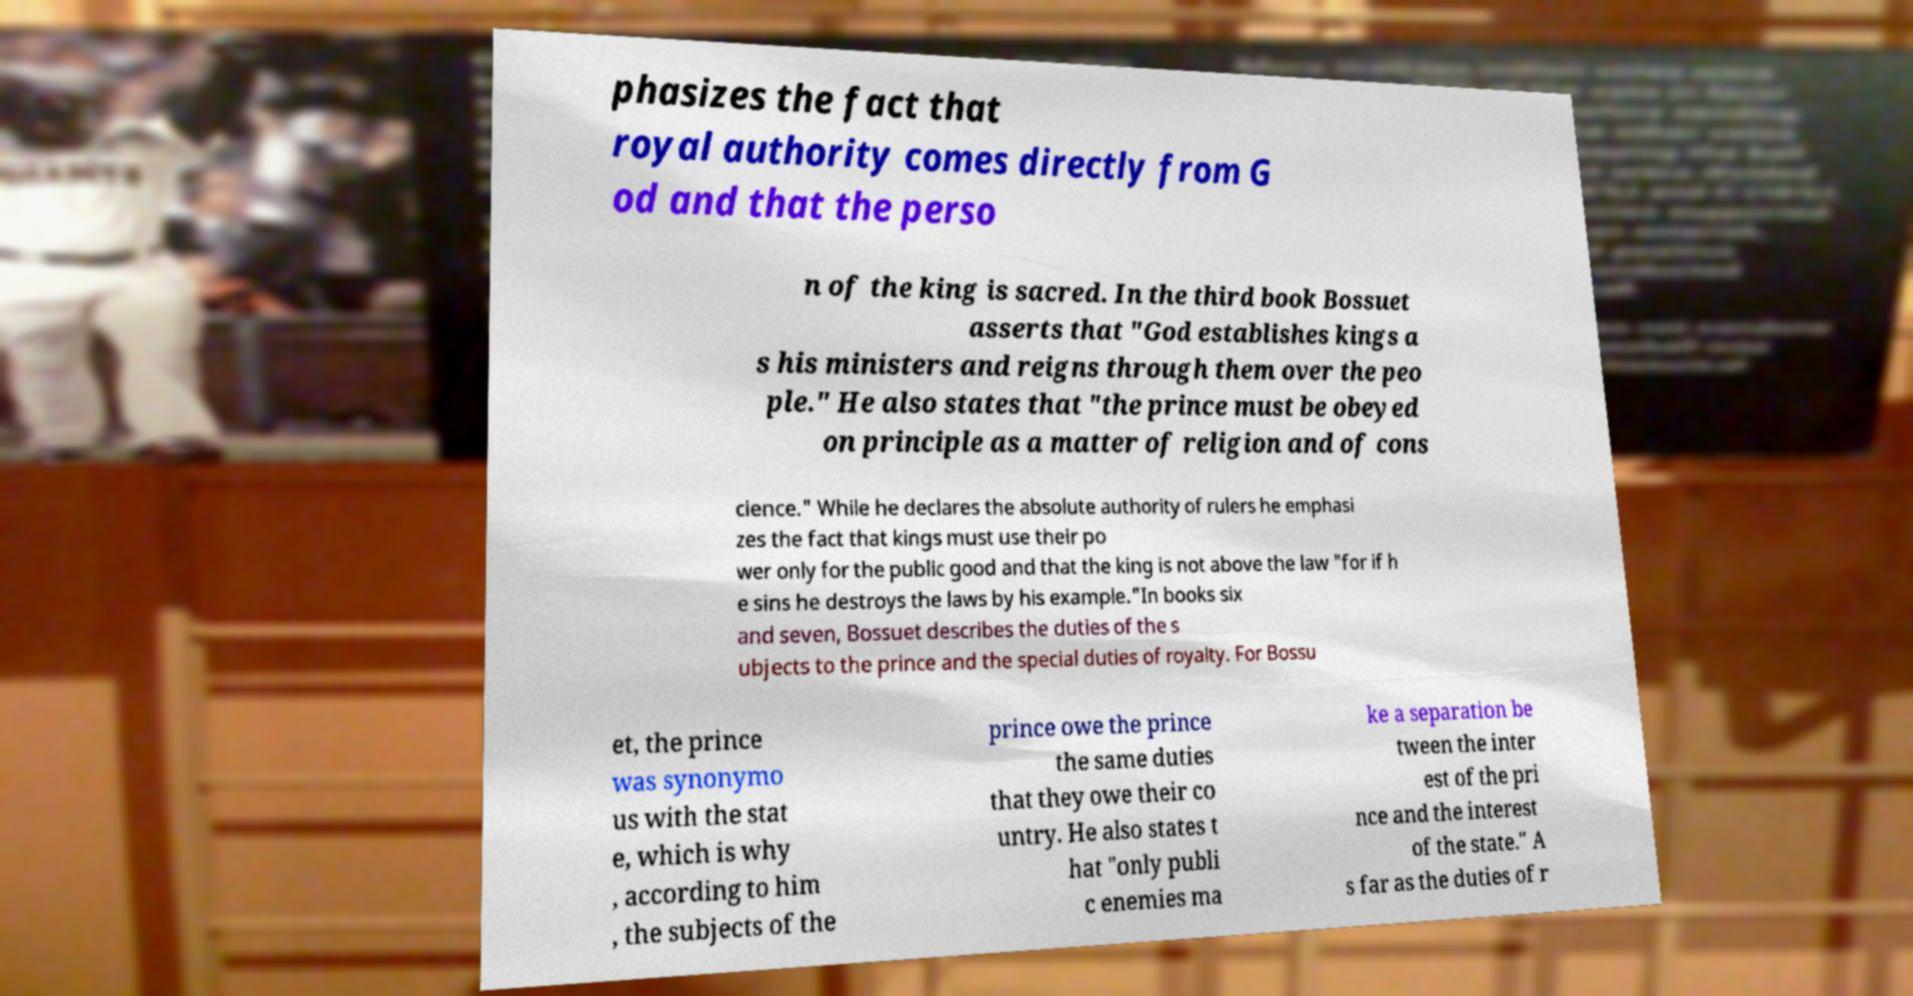Could you assist in decoding the text presented in this image and type it out clearly? phasizes the fact that royal authority comes directly from G od and that the perso n of the king is sacred. In the third book Bossuet asserts that "God establishes kings a s his ministers and reigns through them over the peo ple." He also states that "the prince must be obeyed on principle as a matter of religion and of cons cience." While he declares the absolute authority of rulers he emphasi zes the fact that kings must use their po wer only for the public good and that the king is not above the law "for if h e sins he destroys the laws by his example."In books six and seven, Bossuet describes the duties of the s ubjects to the prince and the special duties of royalty. For Bossu et, the prince was synonymo us with the stat e, which is why , according to him , the subjects of the prince owe the prince the same duties that they owe their co untry. He also states t hat "only publi c enemies ma ke a separation be tween the inter est of the pri nce and the interest of the state." A s far as the duties of r 